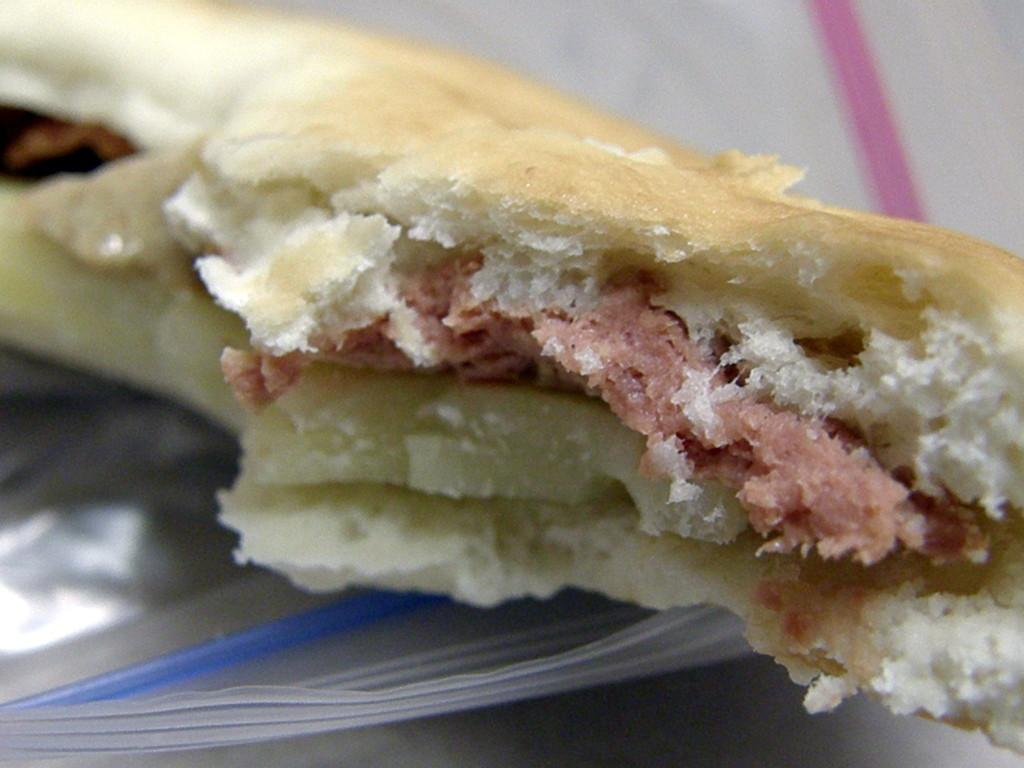What is present in the image? There is food in the image. How is the food being stored or protected? The food is in a cover. What letter is written on the food in the image? There is no letter written on the food in the image. How does the beam of light affect the food in the image? There is no beam of light present in the image. 